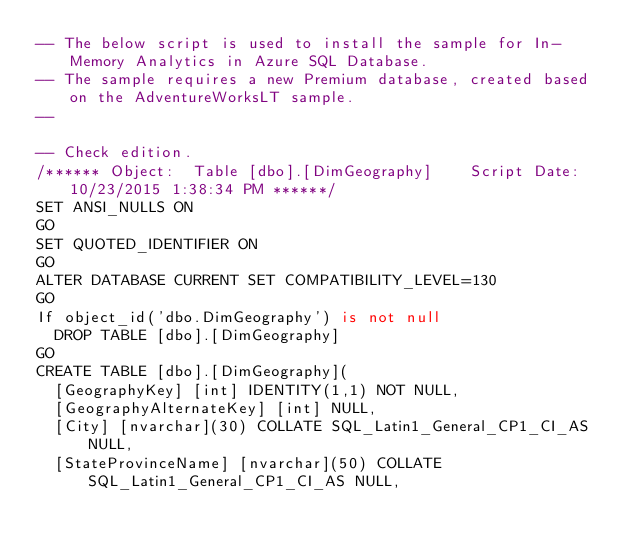Convert code to text. <code><loc_0><loc_0><loc_500><loc_500><_SQL_>-- The below script is used to install the sample for In-Memory Analytics in Azure SQL Database.
-- The sample requires a new Premium database, created based on the AdventureWorksLT sample.
--

-- Check edition.
/****** Object:  Table [dbo].[DimGeography]    Script Date: 10/23/2015 1:38:34 PM ******/
SET ANSI_NULLS ON
GO
SET QUOTED_IDENTIFIER ON
GO
ALTER DATABASE CURRENT SET COMPATIBILITY_LEVEL=130
GO
If object_id('dbo.DimGeography') is not null
	DROP TABLE [dbo].[DimGeography]
GO
CREATE TABLE [dbo].[DimGeography](
	[GeographyKey] [int] IDENTITY(1,1) NOT NULL,
	[GeographyAlternateKey] [int] NULL,
	[City] [nvarchar](30) COLLATE SQL_Latin1_General_CP1_CI_AS NULL,
	[StateProvinceName] [nvarchar](50) COLLATE SQL_Latin1_General_CP1_CI_AS NULL,</code> 